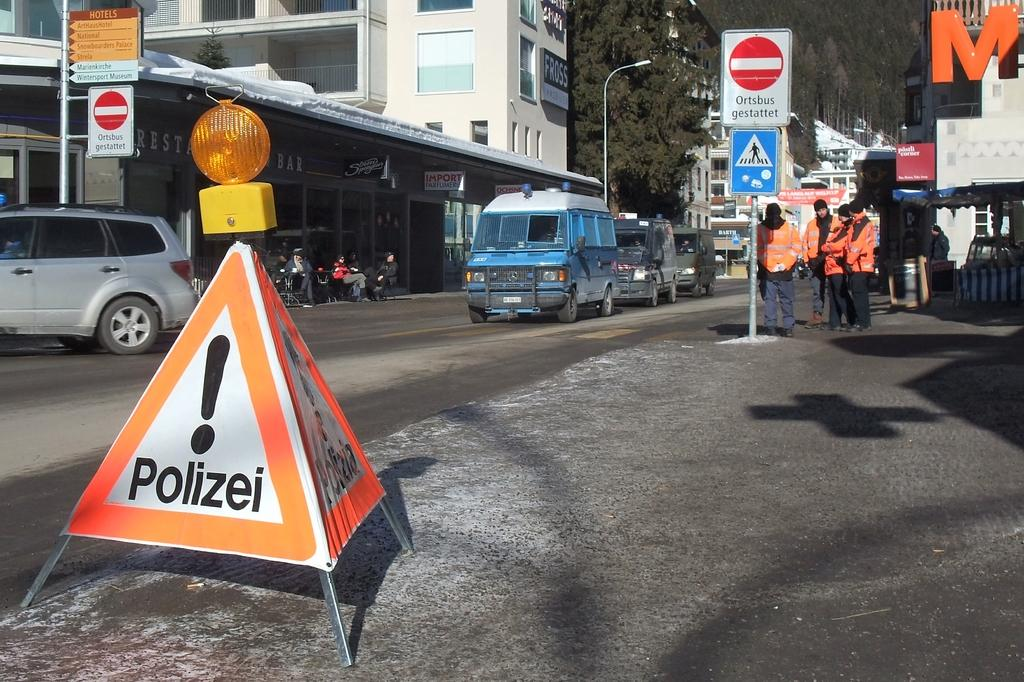Provide a one-sentence caption for the provided image. A road with cars and a triangular sign that has an explanation point and under it the word Polizei is in black letters. 